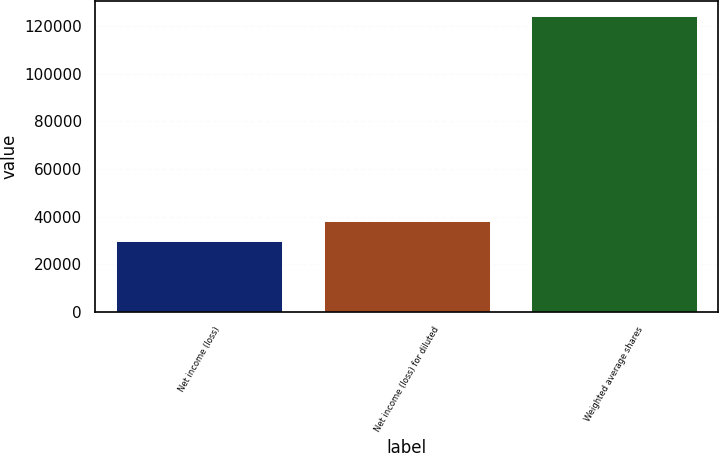<chart> <loc_0><loc_0><loc_500><loc_500><bar_chart><fcel>Net income (loss)<fcel>Net income (loss) for diluted<fcel>Weighted average shares<nl><fcel>29557<fcel>38264.7<fcel>124464<nl></chart> 